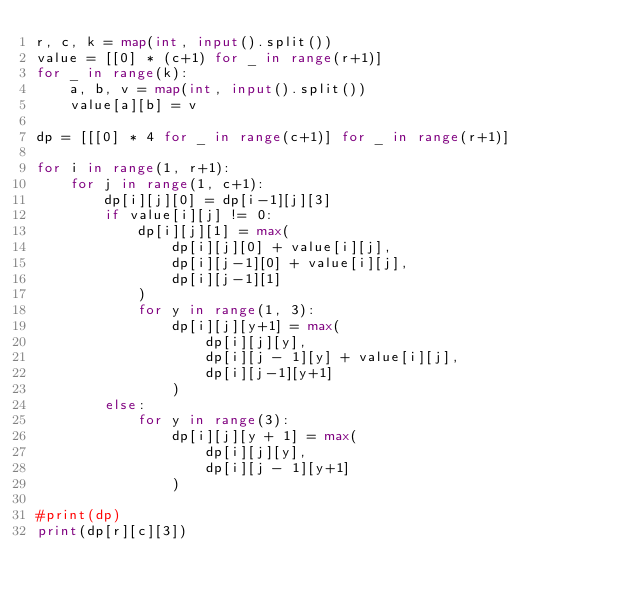Convert code to text. <code><loc_0><loc_0><loc_500><loc_500><_Python_>r, c, k = map(int, input().split())
value = [[0] * (c+1) for _ in range(r+1)]
for _ in range(k):
    a, b, v = map(int, input().split())
    value[a][b] = v

dp = [[[0] * 4 for _ in range(c+1)] for _ in range(r+1)]

for i in range(1, r+1):
    for j in range(1, c+1):
        dp[i][j][0] = dp[i-1][j][3]
        if value[i][j] != 0:
            dp[i][j][1] = max(
                dp[i][j][0] + value[i][j],
                dp[i][j-1][0] + value[i][j],
                dp[i][j-1][1]
            )
            for y in range(1, 3):
                dp[i][j][y+1] = max(
                    dp[i][j][y],
                    dp[i][j - 1][y] + value[i][j],
                    dp[i][j-1][y+1]
                )
        else:
            for y in range(3):
                dp[i][j][y + 1] = max(
                    dp[i][j][y],
                    dp[i][j - 1][y+1]
                )

#print(dp)
print(dp[r][c][3])
</code> 